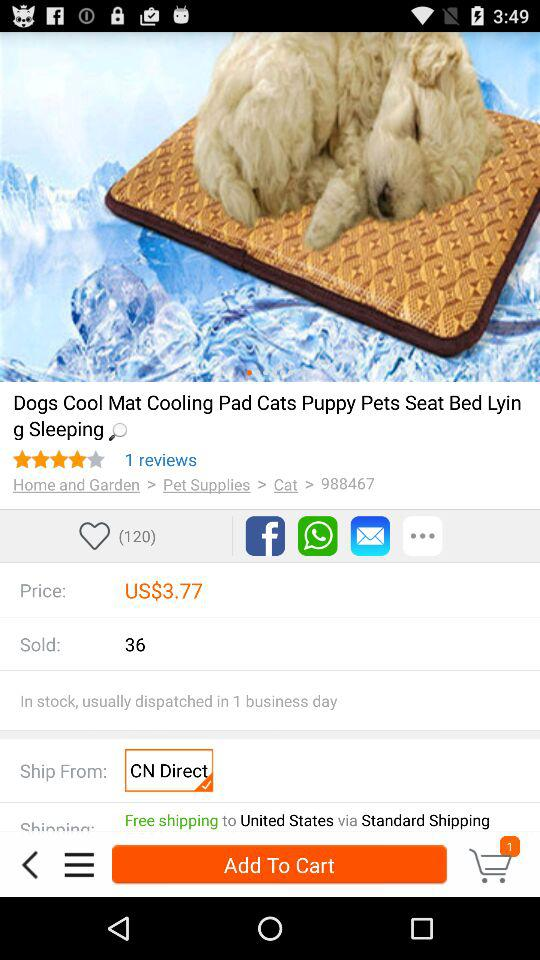How many rating stars were given for the "Dogs Cool Mats"? There are 4 rating stars. 